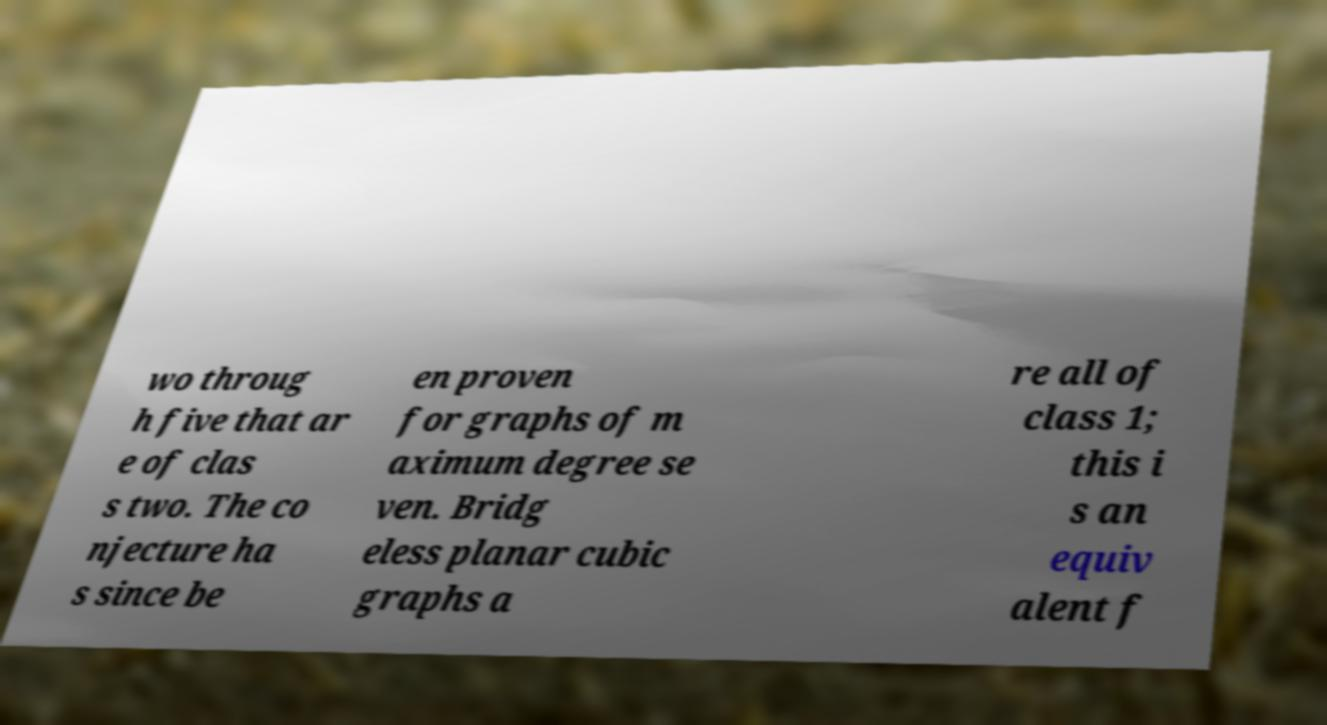I need the written content from this picture converted into text. Can you do that? wo throug h five that ar e of clas s two. The co njecture ha s since be en proven for graphs of m aximum degree se ven. Bridg eless planar cubic graphs a re all of class 1; this i s an equiv alent f 